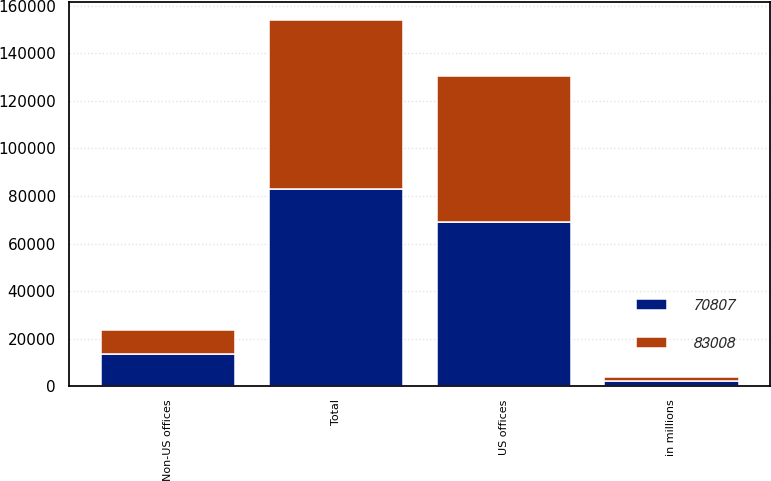<chart> <loc_0><loc_0><loc_500><loc_500><stacked_bar_chart><ecel><fcel>in millions<fcel>US offices<fcel>Non-US offices<fcel>Total<nl><fcel>70807<fcel>2014<fcel>69270<fcel>13738<fcel>83008<nl><fcel>83008<fcel>2013<fcel>61016<fcel>9791<fcel>70807<nl></chart> 